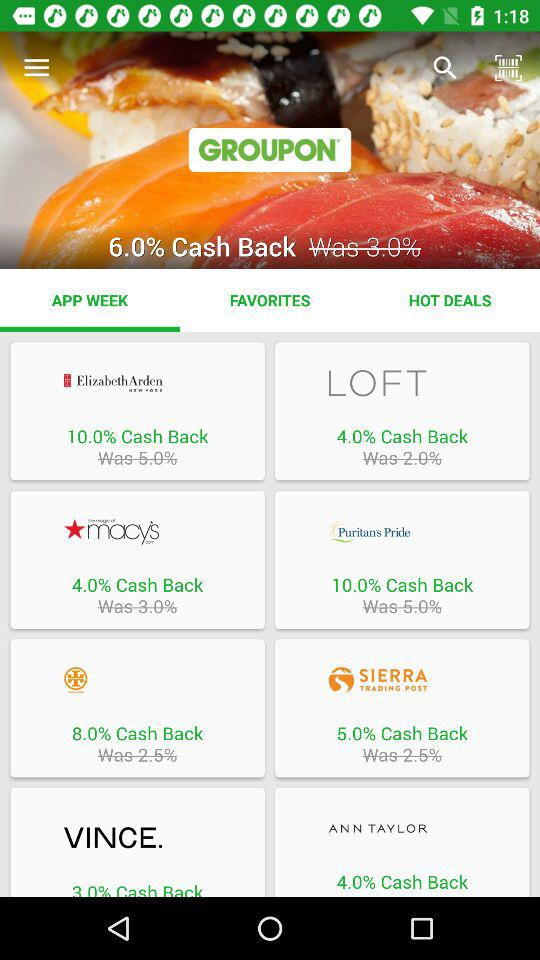How many percent cash back is available on Puritans Pride?
Answer the question using a single word or phrase. 10.0% 